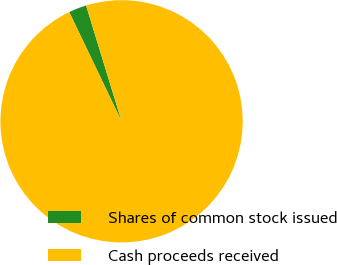<chart> <loc_0><loc_0><loc_500><loc_500><pie_chart><fcel>Shares of common stock issued<fcel>Cash proceeds received<nl><fcel>2.38%<fcel>97.62%<nl></chart> 